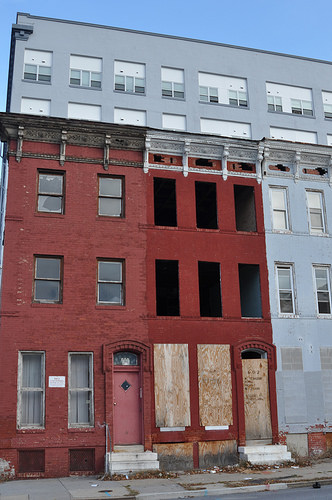<image>
Is there a board in the building? Yes. The board is contained within or inside the building, showing a containment relationship. Is there a window in the building? Yes. The window is contained within or inside the building, showing a containment relationship. 